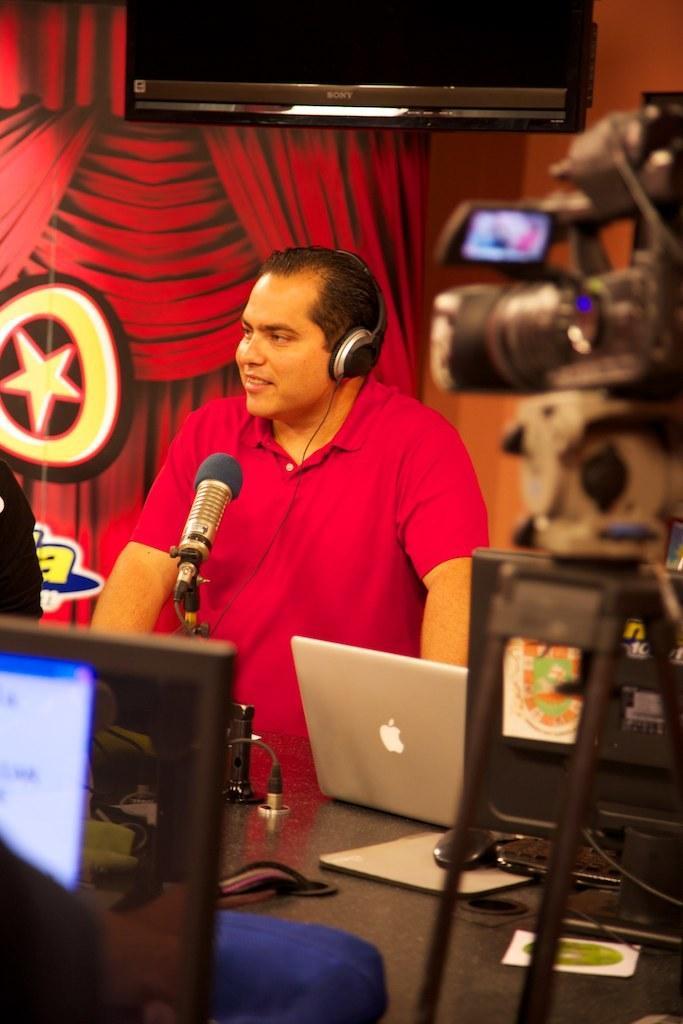In one or two sentences, can you explain what this image depicts? In the foreground of the image we can see a laptop and a monitor. In the middle of the image we can see a person standing in front of a mike and wearing a headset and a camera is there. At the top of the image we can see the curtain and a screen. 